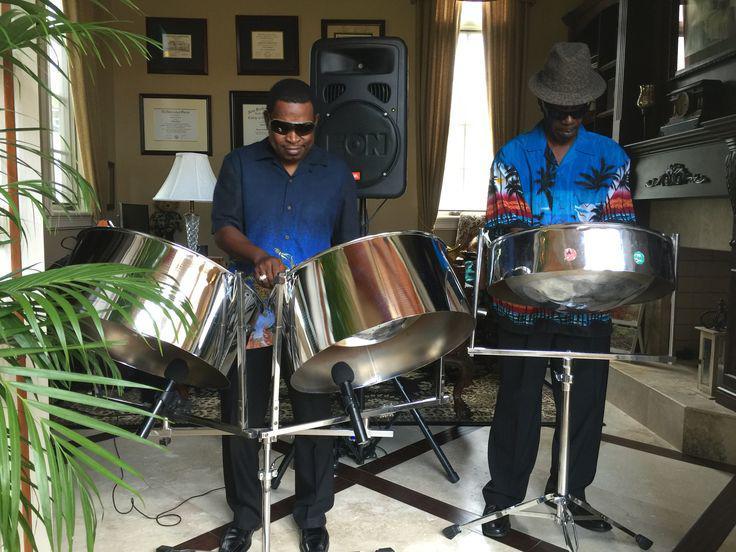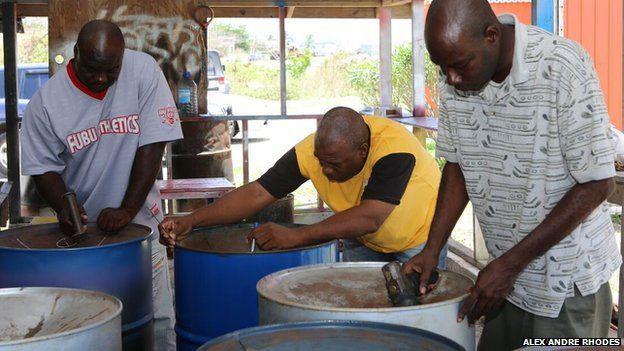The first image is the image on the left, the second image is the image on the right. Assess this claim about the two images: "There is at least one person wearing a hat.". Correct or not? Answer yes or no. Yes. 